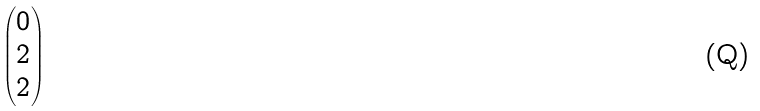<formula> <loc_0><loc_0><loc_500><loc_500>\begin{pmatrix} 0 \\ 2 \\ 2 \end{pmatrix}</formula> 